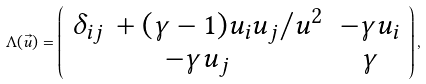Convert formula to latex. <formula><loc_0><loc_0><loc_500><loc_500>\Lambda ( \vec { u } ) = \left ( \begin{array} { c c } \delta _ { i j } \, + ( \gamma - 1 ) u _ { i } u _ { j } / u ^ { 2 } & - \gamma u _ { i } \\ - \gamma u _ { j } & \gamma \\ \end{array} \right ) ,</formula> 